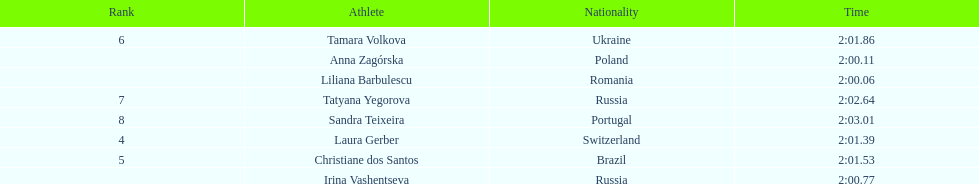What was anna zagorska's time when she achieved the second position? 2:00.11. 